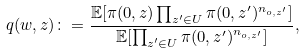Convert formula to latex. <formula><loc_0><loc_0><loc_500><loc_500>q ( w , z ) \colon = \frac { \mathbb { E } [ \pi ( 0 , z ) \prod _ { z ^ { \prime } \in U } \pi ( 0 , z ^ { \prime } ) ^ { n _ { o , z ^ { \prime } } } ] } { \mathbb { E } [ \prod _ { z ^ { \prime } \in U } \pi ( 0 , z ^ { \prime } ) ^ { n _ { o , z ^ { \prime } } } ] } ,</formula> 